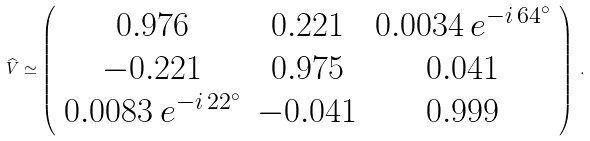Convert formula to latex. <formula><loc_0><loc_0><loc_500><loc_500>\widehat { V } \simeq \left ( \begin{array} { c c c } 0 . 9 7 6 & 0 . 2 2 1 & 0 . 0 0 3 4 \, e ^ { - i \, 6 4 ^ { \circ } } \\ - 0 . 2 2 1 & 0 . 9 7 5 & 0 . 0 4 1 \\ 0 . 0 0 8 3 \, e ^ { - i \, 2 2 ^ { \circ } } & - 0 . 0 4 1 & 0 . 9 9 9 \end{array} \right ) \, .</formula> 